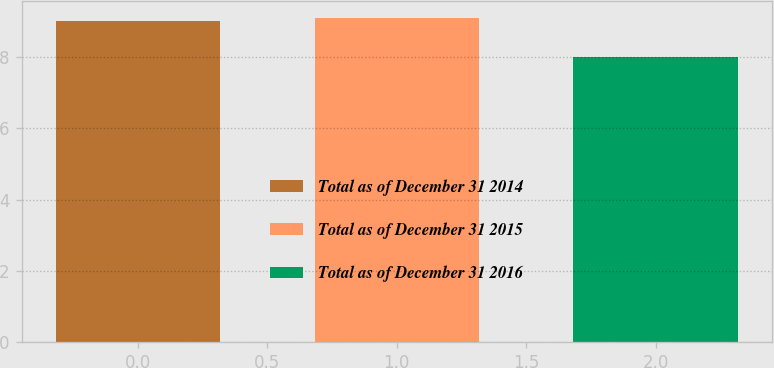Convert chart. <chart><loc_0><loc_0><loc_500><loc_500><bar_chart><fcel>Total as of December 31 2014<fcel>Total as of December 31 2015<fcel>Total as of December 31 2016<nl><fcel>9<fcel>9.1<fcel>8<nl></chart> 